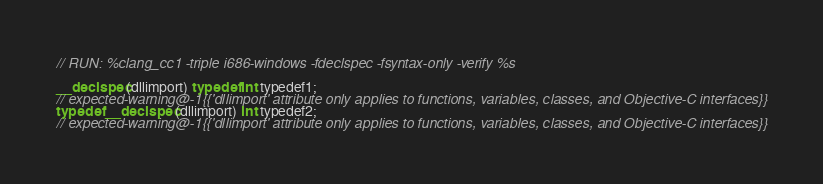<code> <loc_0><loc_0><loc_500><loc_500><_ObjectiveC_>// RUN: %clang_cc1 -triple i686-windows -fdeclspec -fsyntax-only -verify %s

__declspec(dllimport) typedef int typedef1;
// expected-warning@-1{{'dllimport' attribute only applies to functions, variables, classes, and Objective-C interfaces}}
typedef __declspec(dllimport) int typedef2;
// expected-warning@-1{{'dllimport' attribute only applies to functions, variables, classes, and Objective-C interfaces}}</code> 